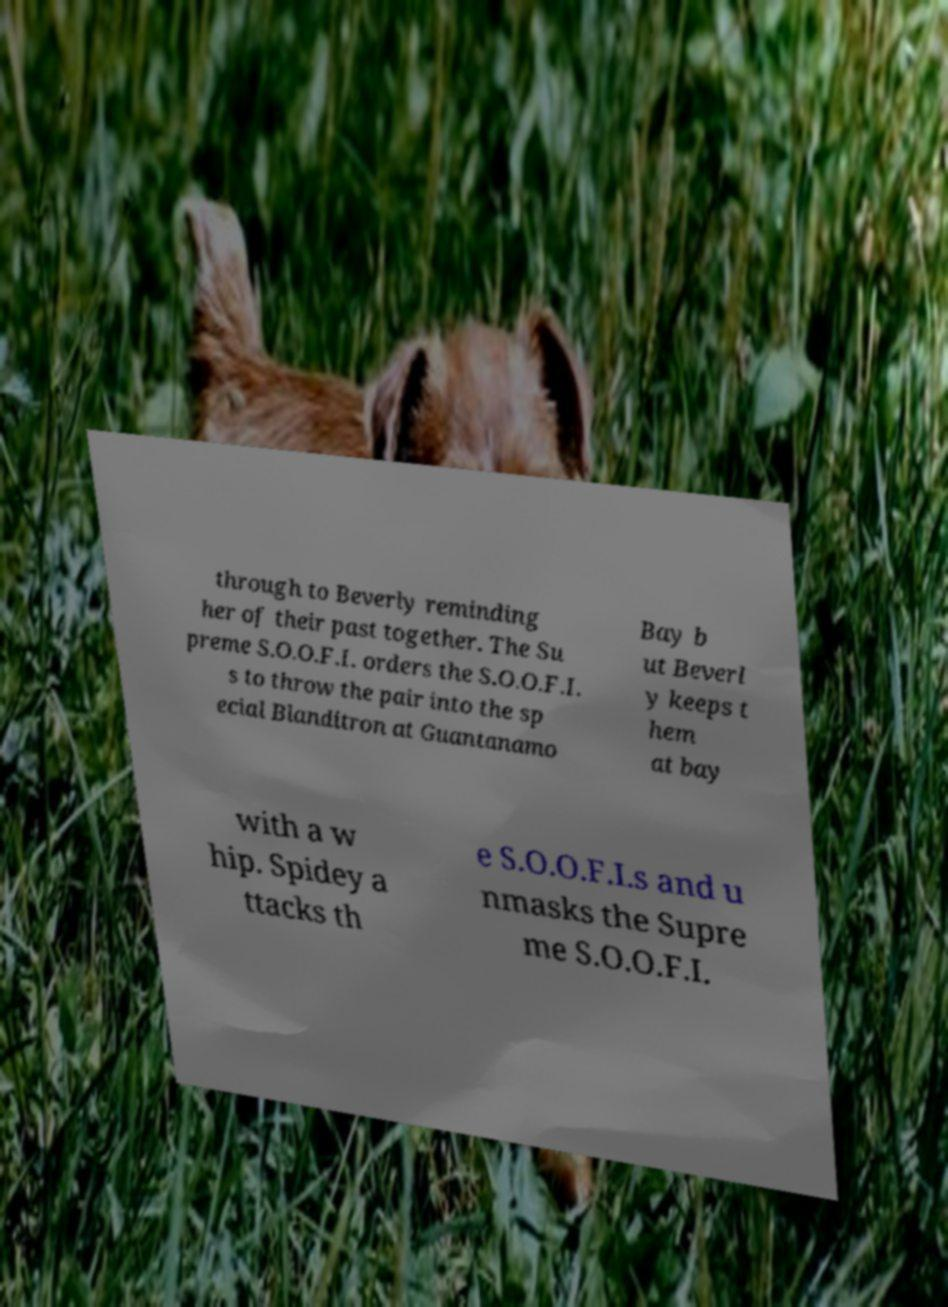Can you read and provide the text displayed in the image?This photo seems to have some interesting text. Can you extract and type it out for me? through to Beverly reminding her of their past together. The Su preme S.O.O.F.I. orders the S.O.O.F.I. s to throw the pair into the sp ecial Blanditron at Guantanamo Bay b ut Beverl y keeps t hem at bay with a w hip. Spidey a ttacks th e S.O.O.F.I.s and u nmasks the Supre me S.O.O.F.I. 